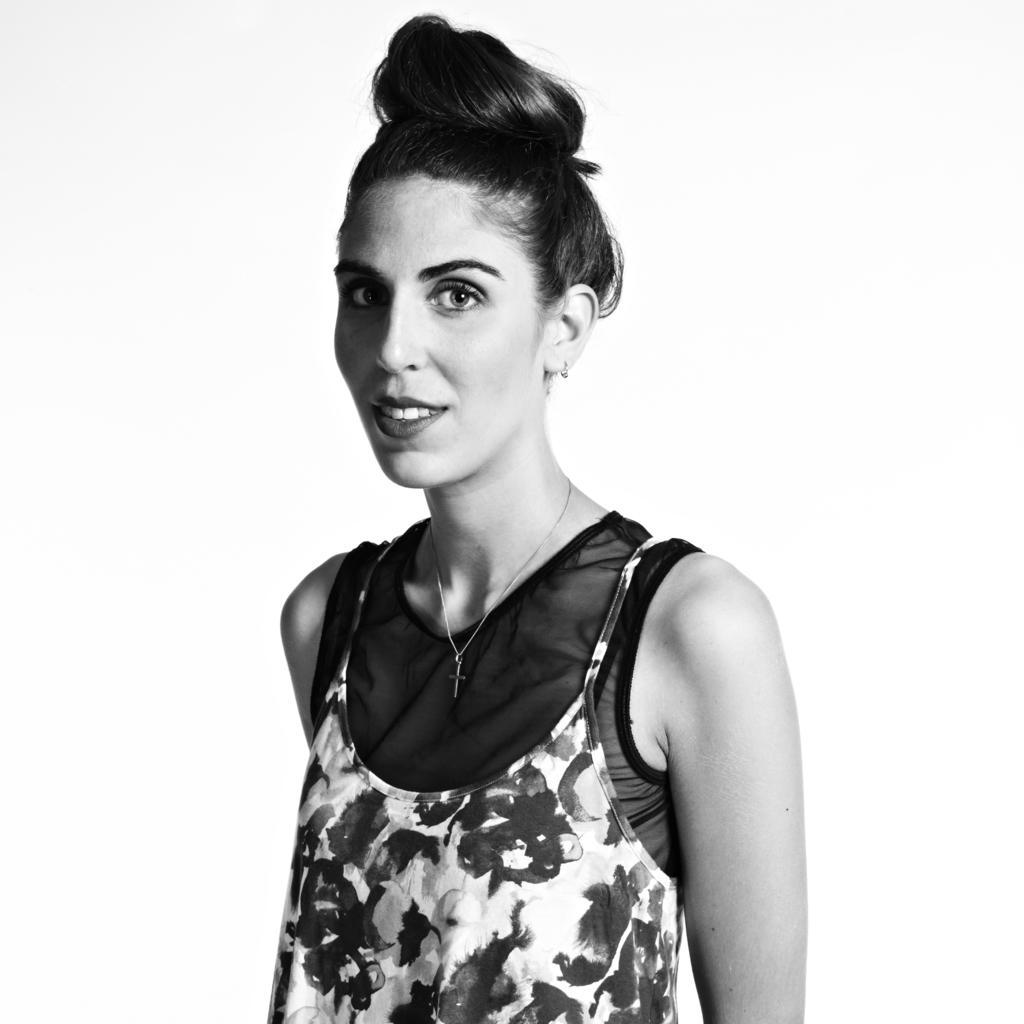How would you summarize this image in a sentence or two? In this picture there is a woman with floral dress is standing and smiling. At the back there is a white background. 